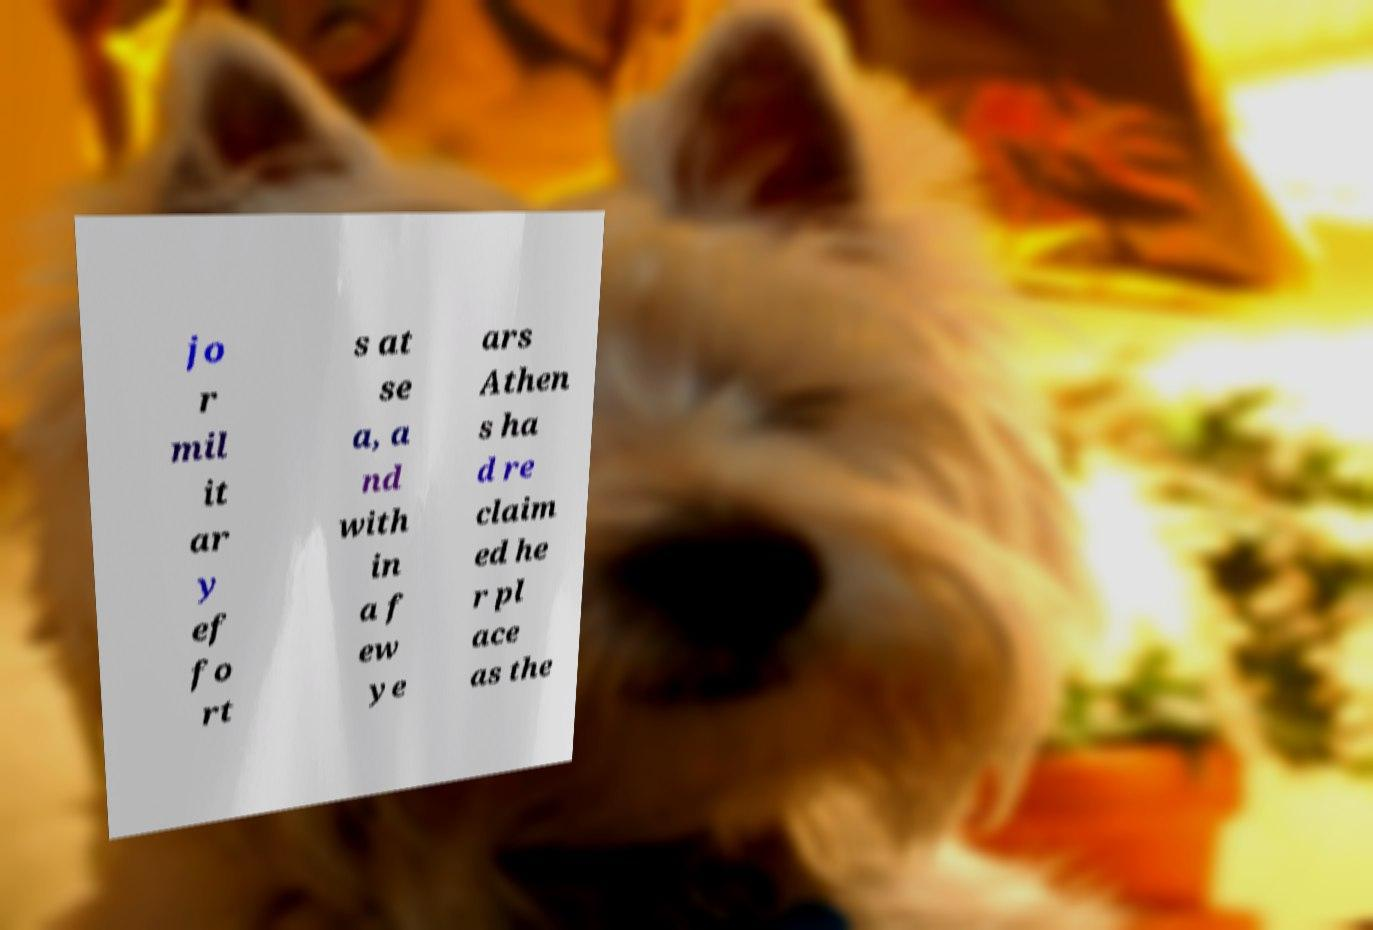Could you extract and type out the text from this image? jo r mil it ar y ef fo rt s at se a, a nd with in a f ew ye ars Athen s ha d re claim ed he r pl ace as the 